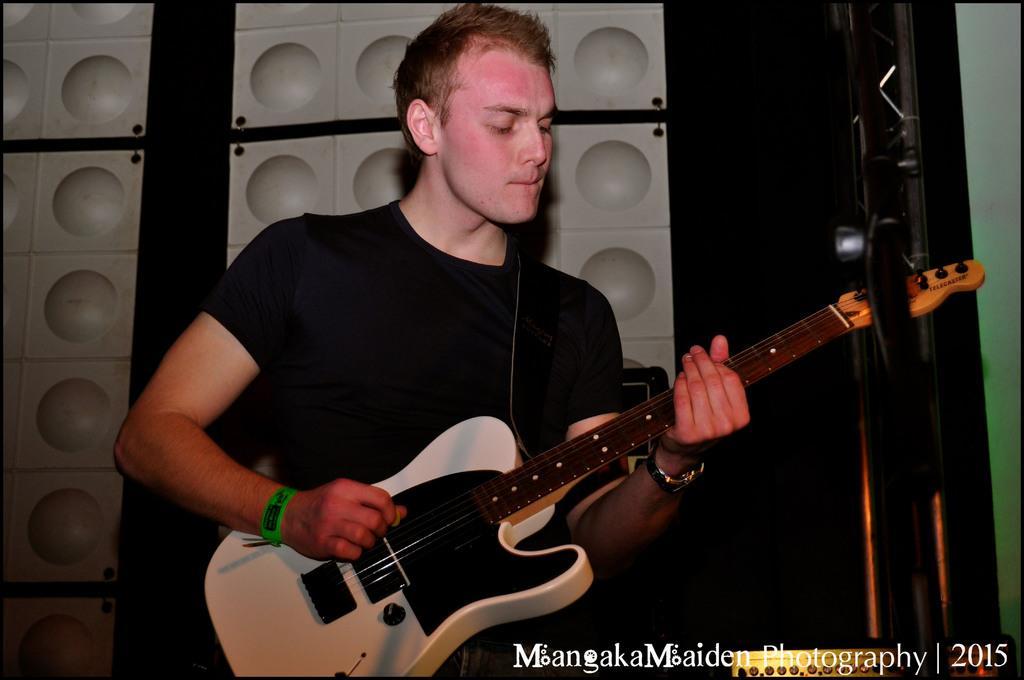In one or two sentences, can you explain what this image depicts? In this image I can see there is a person playing guitar and I can see there is something written at the bottom of the image and there is a white surface in the background. 